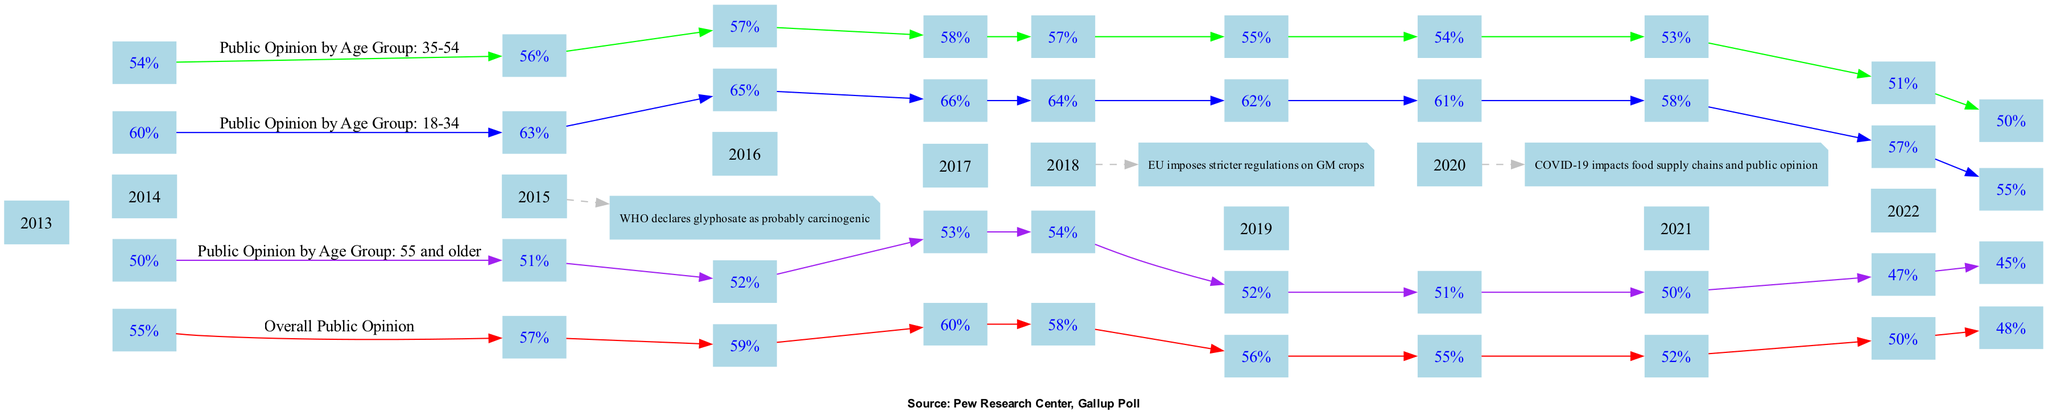What was the overall public opinion percentage in 2020? The diagram presents a line for overall public opinion across years. Looking at the data points for the year 2020, the percentage approval listed is 52%.
Answer: 52% What percentage did the age group 55 and older have in 2018? By inspecting the line representing the 55 and older demographic for the year 2018, the percentage approval is found to be 52%.
Answer: 52% Which demographic had the highest public opinion percentage in 2015? Checking the data points for 2015 across all demographic lines, the age group 18-34 has the highest percentage at 65%.
Answer: 65% How many total lines representing different demographics are in the diagram? The diagram contains a total of four distinct lines: Overall Public Opinion and three age groups. Therefore, the total is four lines.
Answer: 4 What was the trend in overall public opinion from 2013 to 2022? Examining the data points for overall public opinion from 2013 to 2022, we see a downward trend, starting at 55% in 2013 and decreasing to 48% in 2022.
Answer: Downward trend What significant event occurred in 2018 that might have influenced public opinion? The note accompanying the year 2018 states that "EU imposes stricter regulations on GM crops," which likely impacted the public's perception regarding genetically modified crops.
Answer: EU imposes stricter regulations on GM crops In which year did public opinion from the age group 35-54 drop to 50%? Tracing the age group 35-54 line down to its data points, it can be seen that the percentage dropped to 50% in the year 2022.
Answer: 2022 What color is used to represent the public opinion line for the age group 18-34? The diagram uses a color coding system for demographic lines, and the line for the age group 18-34 is represented using the color blue.
Answer: Blue Which age group had the lowest percentage approval in 2021? A comparison of the percentage approvals for all demographic lines in 2021 reveals that the age group 55 and older had the lowest percentage at 47%.
Answer: 47% 